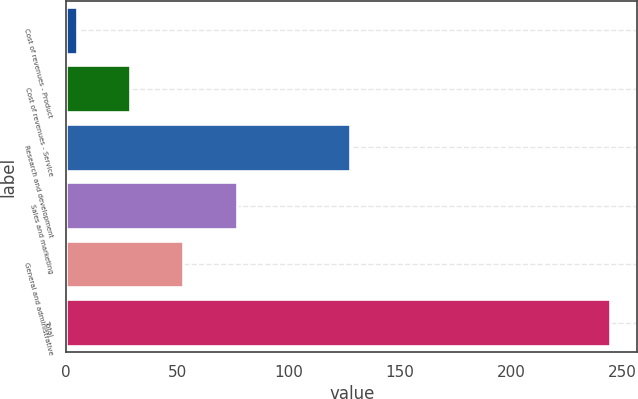Convert chart. <chart><loc_0><loc_0><loc_500><loc_500><bar_chart><fcel>Cost of revenues - Product<fcel>Cost of revenues - Service<fcel>Research and development<fcel>Sales and marketing<fcel>General and administrative<fcel>Total<nl><fcel>4.7<fcel>28.69<fcel>127.6<fcel>76.67<fcel>52.68<fcel>244.6<nl></chart> 